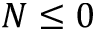Convert formula to latex. <formula><loc_0><loc_0><loc_500><loc_500>N \leq 0</formula> 